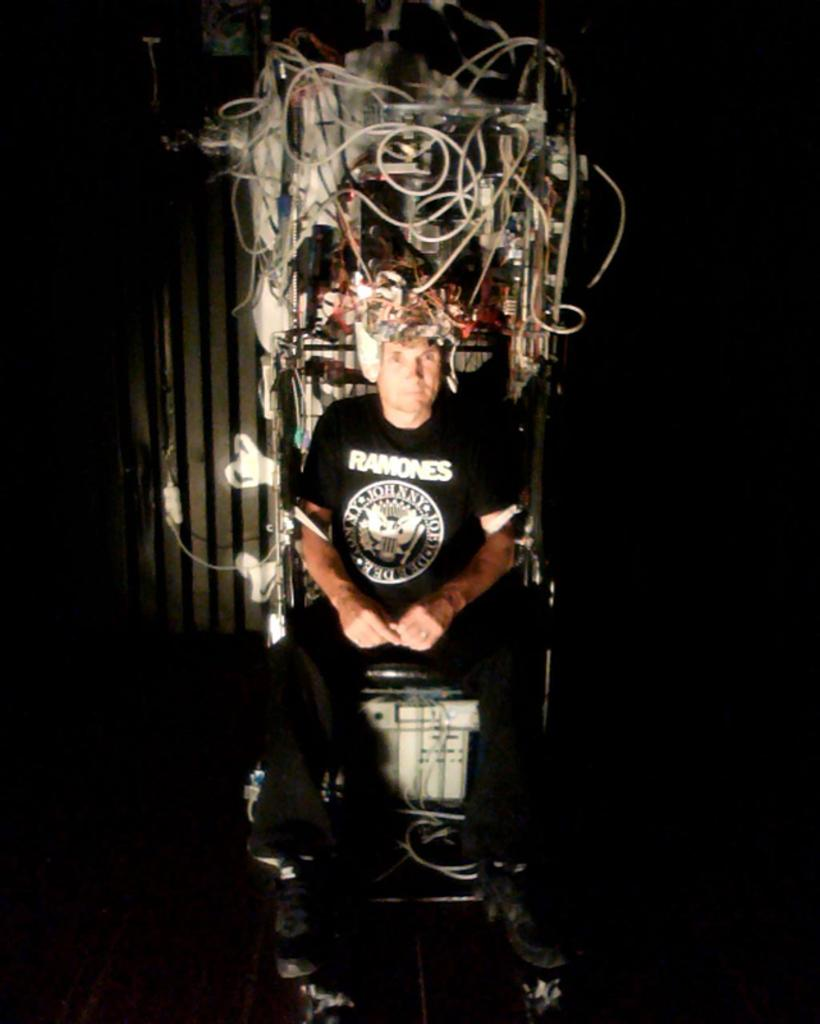What is the main subject of the image? The main subject of the image is a man. What is the man doing in the image? The man is seated on a chair in the image. What is the man wearing in the image? The man is wearing a black dress in the image. What type of experience does the man have with the lamp in the image? There is no lamp present in the image, so it is not possible to determine any experience the man might have with a lamp. 